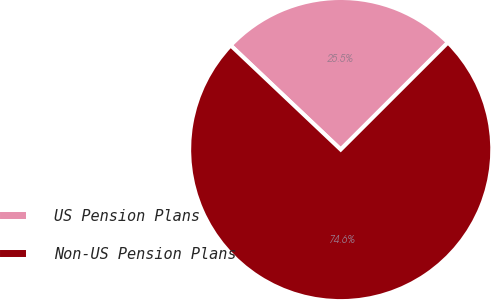Convert chart. <chart><loc_0><loc_0><loc_500><loc_500><pie_chart><fcel>US Pension Plans<fcel>Non-US Pension Plans<nl><fcel>25.45%<fcel>74.55%<nl></chart> 